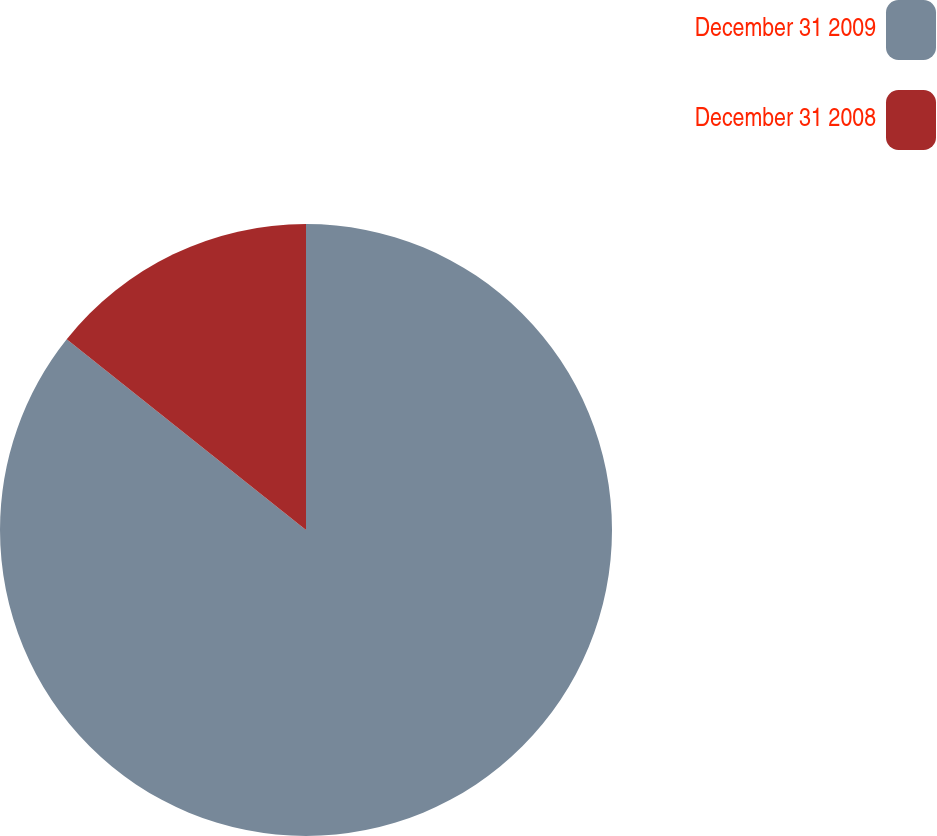Convert chart to OTSL. <chart><loc_0><loc_0><loc_500><loc_500><pie_chart><fcel>December 31 2009<fcel>December 31 2008<nl><fcel>85.71%<fcel>14.29%<nl></chart> 